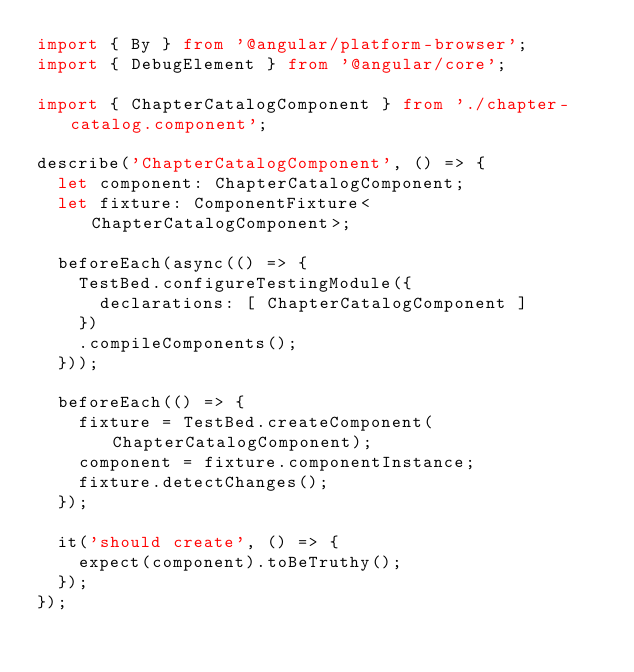Convert code to text. <code><loc_0><loc_0><loc_500><loc_500><_TypeScript_>import { By } from '@angular/platform-browser';
import { DebugElement } from '@angular/core';

import { ChapterCatalogComponent } from './chapter-catalog.component';

describe('ChapterCatalogComponent', () => {
  let component: ChapterCatalogComponent;
  let fixture: ComponentFixture<ChapterCatalogComponent>;

  beforeEach(async(() => {
    TestBed.configureTestingModule({
      declarations: [ ChapterCatalogComponent ]
    })
    .compileComponents();
  }));

  beforeEach(() => {
    fixture = TestBed.createComponent(ChapterCatalogComponent);
    component = fixture.componentInstance;
    fixture.detectChanges();
  });

  it('should create', () => {
    expect(component).toBeTruthy();
  });
});
</code> 